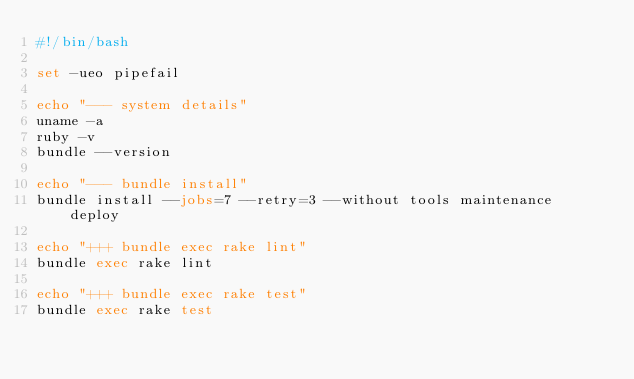<code> <loc_0><loc_0><loc_500><loc_500><_Bash_>#!/bin/bash

set -ueo pipefail

echo "--- system details"
uname -a
ruby -v
bundle --version

echo "--- bundle install"
bundle install --jobs=7 --retry=3 --without tools maintenance deploy

echo "+++ bundle exec rake lint"
bundle exec rake lint

echo "+++ bundle exec rake test"
bundle exec rake test
</code> 